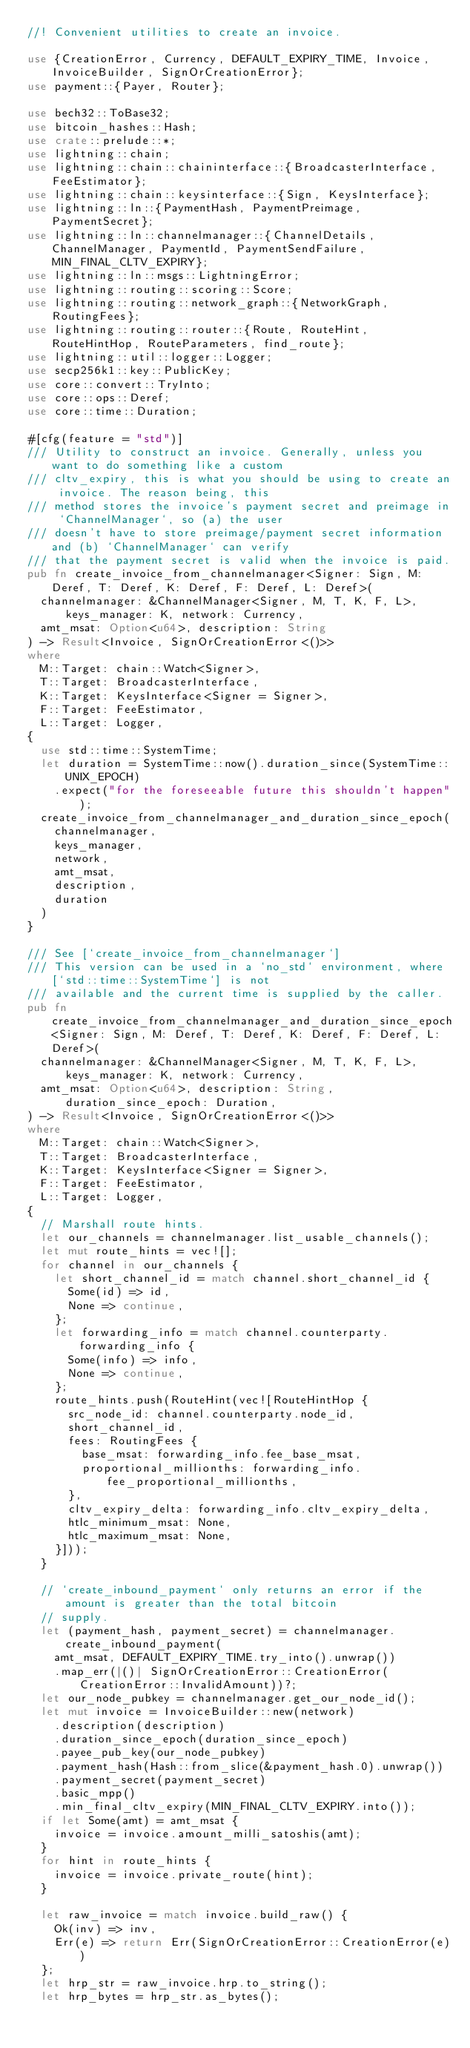Convert code to text. <code><loc_0><loc_0><loc_500><loc_500><_Rust_>//! Convenient utilities to create an invoice.

use {CreationError, Currency, DEFAULT_EXPIRY_TIME, Invoice, InvoiceBuilder, SignOrCreationError};
use payment::{Payer, Router};

use bech32::ToBase32;
use bitcoin_hashes::Hash;
use crate::prelude::*;
use lightning::chain;
use lightning::chain::chaininterface::{BroadcasterInterface, FeeEstimator};
use lightning::chain::keysinterface::{Sign, KeysInterface};
use lightning::ln::{PaymentHash, PaymentPreimage, PaymentSecret};
use lightning::ln::channelmanager::{ChannelDetails, ChannelManager, PaymentId, PaymentSendFailure, MIN_FINAL_CLTV_EXPIRY};
use lightning::ln::msgs::LightningError;
use lightning::routing::scoring::Score;
use lightning::routing::network_graph::{NetworkGraph, RoutingFees};
use lightning::routing::router::{Route, RouteHint, RouteHintHop, RouteParameters, find_route};
use lightning::util::logger::Logger;
use secp256k1::key::PublicKey;
use core::convert::TryInto;
use core::ops::Deref;
use core::time::Duration;

#[cfg(feature = "std")]
/// Utility to construct an invoice. Generally, unless you want to do something like a custom
/// cltv_expiry, this is what you should be using to create an invoice. The reason being, this
/// method stores the invoice's payment secret and preimage in `ChannelManager`, so (a) the user
/// doesn't have to store preimage/payment secret information and (b) `ChannelManager` can verify
/// that the payment secret is valid when the invoice is paid.
pub fn create_invoice_from_channelmanager<Signer: Sign, M: Deref, T: Deref, K: Deref, F: Deref, L: Deref>(
	channelmanager: &ChannelManager<Signer, M, T, K, F, L>, keys_manager: K, network: Currency,
	amt_msat: Option<u64>, description: String
) -> Result<Invoice, SignOrCreationError<()>>
where
	M::Target: chain::Watch<Signer>,
	T::Target: BroadcasterInterface,
	K::Target: KeysInterface<Signer = Signer>,
	F::Target: FeeEstimator,
	L::Target: Logger,
{
	use std::time::SystemTime;
	let duration = SystemTime::now().duration_since(SystemTime::UNIX_EPOCH)
		.expect("for the foreseeable future this shouldn't happen");
	create_invoice_from_channelmanager_and_duration_since_epoch(
		channelmanager,
		keys_manager,
		network,
		amt_msat,
		description,
		duration
	)
}

/// See [`create_invoice_from_channelmanager`]
/// This version can be used in a `no_std` environment, where [`std::time::SystemTime`] is not
/// available and the current time is supplied by the caller.
pub fn create_invoice_from_channelmanager_and_duration_since_epoch<Signer: Sign, M: Deref, T: Deref, K: Deref, F: Deref, L: Deref>(
	channelmanager: &ChannelManager<Signer, M, T, K, F, L>, keys_manager: K, network: Currency,
	amt_msat: Option<u64>, description: String, duration_since_epoch: Duration,
) -> Result<Invoice, SignOrCreationError<()>>
where
	M::Target: chain::Watch<Signer>,
	T::Target: BroadcasterInterface,
	K::Target: KeysInterface<Signer = Signer>,
	F::Target: FeeEstimator,
	L::Target: Logger,
{
	// Marshall route hints.
	let our_channels = channelmanager.list_usable_channels();
	let mut route_hints = vec![];
	for channel in our_channels {
		let short_channel_id = match channel.short_channel_id {
			Some(id) => id,
			None => continue,
		};
		let forwarding_info = match channel.counterparty.forwarding_info {
			Some(info) => info,
			None => continue,
		};
		route_hints.push(RouteHint(vec![RouteHintHop {
			src_node_id: channel.counterparty.node_id,
			short_channel_id,
			fees: RoutingFees {
				base_msat: forwarding_info.fee_base_msat,
				proportional_millionths: forwarding_info.fee_proportional_millionths,
			},
			cltv_expiry_delta: forwarding_info.cltv_expiry_delta,
			htlc_minimum_msat: None,
			htlc_maximum_msat: None,
		}]));
	}

	// `create_inbound_payment` only returns an error if the amount is greater than the total bitcoin
	// supply.
	let (payment_hash, payment_secret) = channelmanager.create_inbound_payment(
		amt_msat, DEFAULT_EXPIRY_TIME.try_into().unwrap())
		.map_err(|()| SignOrCreationError::CreationError(CreationError::InvalidAmount))?;
	let our_node_pubkey = channelmanager.get_our_node_id();
	let mut invoice = InvoiceBuilder::new(network)
		.description(description)
		.duration_since_epoch(duration_since_epoch)
		.payee_pub_key(our_node_pubkey)
		.payment_hash(Hash::from_slice(&payment_hash.0).unwrap())
		.payment_secret(payment_secret)
		.basic_mpp()
		.min_final_cltv_expiry(MIN_FINAL_CLTV_EXPIRY.into());
	if let Some(amt) = amt_msat {
		invoice = invoice.amount_milli_satoshis(amt);
	}
	for hint in route_hints {
		invoice = invoice.private_route(hint);
	}

	let raw_invoice = match invoice.build_raw() {
		Ok(inv) => inv,
		Err(e) => return Err(SignOrCreationError::CreationError(e))
	};
	let hrp_str = raw_invoice.hrp.to_string();
	let hrp_bytes = hrp_str.as_bytes();</code> 